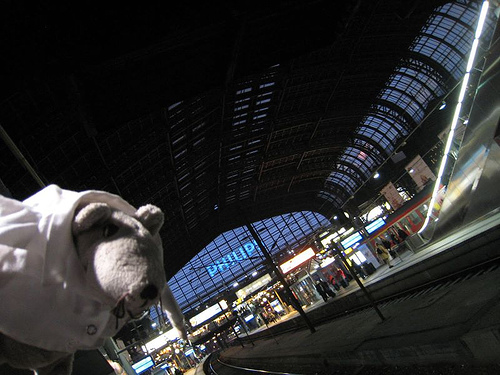<image>
Can you confirm if the stuffed animal is on the track? No. The stuffed animal is not positioned on the track. They may be near each other, but the stuffed animal is not supported by or resting on top of the track. 